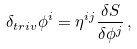<formula> <loc_0><loc_0><loc_500><loc_500>\delta _ { t r i v } \phi ^ { i } = \eta ^ { i j } \frac { \delta S } { \delta \phi ^ { j } } \, ,</formula> 